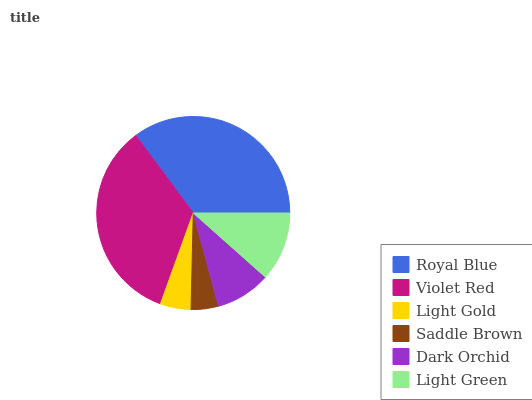Is Saddle Brown the minimum?
Answer yes or no. Yes. Is Royal Blue the maximum?
Answer yes or no. Yes. Is Violet Red the minimum?
Answer yes or no. No. Is Violet Red the maximum?
Answer yes or no. No. Is Royal Blue greater than Violet Red?
Answer yes or no. Yes. Is Violet Red less than Royal Blue?
Answer yes or no. Yes. Is Violet Red greater than Royal Blue?
Answer yes or no. No. Is Royal Blue less than Violet Red?
Answer yes or no. No. Is Light Green the high median?
Answer yes or no. Yes. Is Dark Orchid the low median?
Answer yes or no. Yes. Is Saddle Brown the high median?
Answer yes or no. No. Is Light Gold the low median?
Answer yes or no. No. 